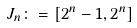Convert formula to latex. <formula><loc_0><loc_0><loc_500><loc_500>J _ { n } \colon = [ 2 ^ { n } - 1 , 2 ^ { n } ]</formula> 